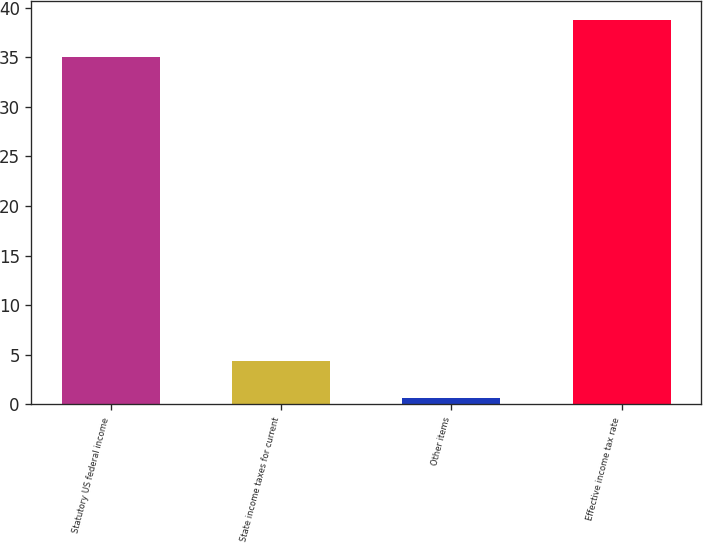Convert chart. <chart><loc_0><loc_0><loc_500><loc_500><bar_chart><fcel>Statutory US federal income<fcel>State income taxes for current<fcel>Other items<fcel>Effective income tax rate<nl><fcel>35<fcel>4.37<fcel>0.6<fcel>38.77<nl></chart> 